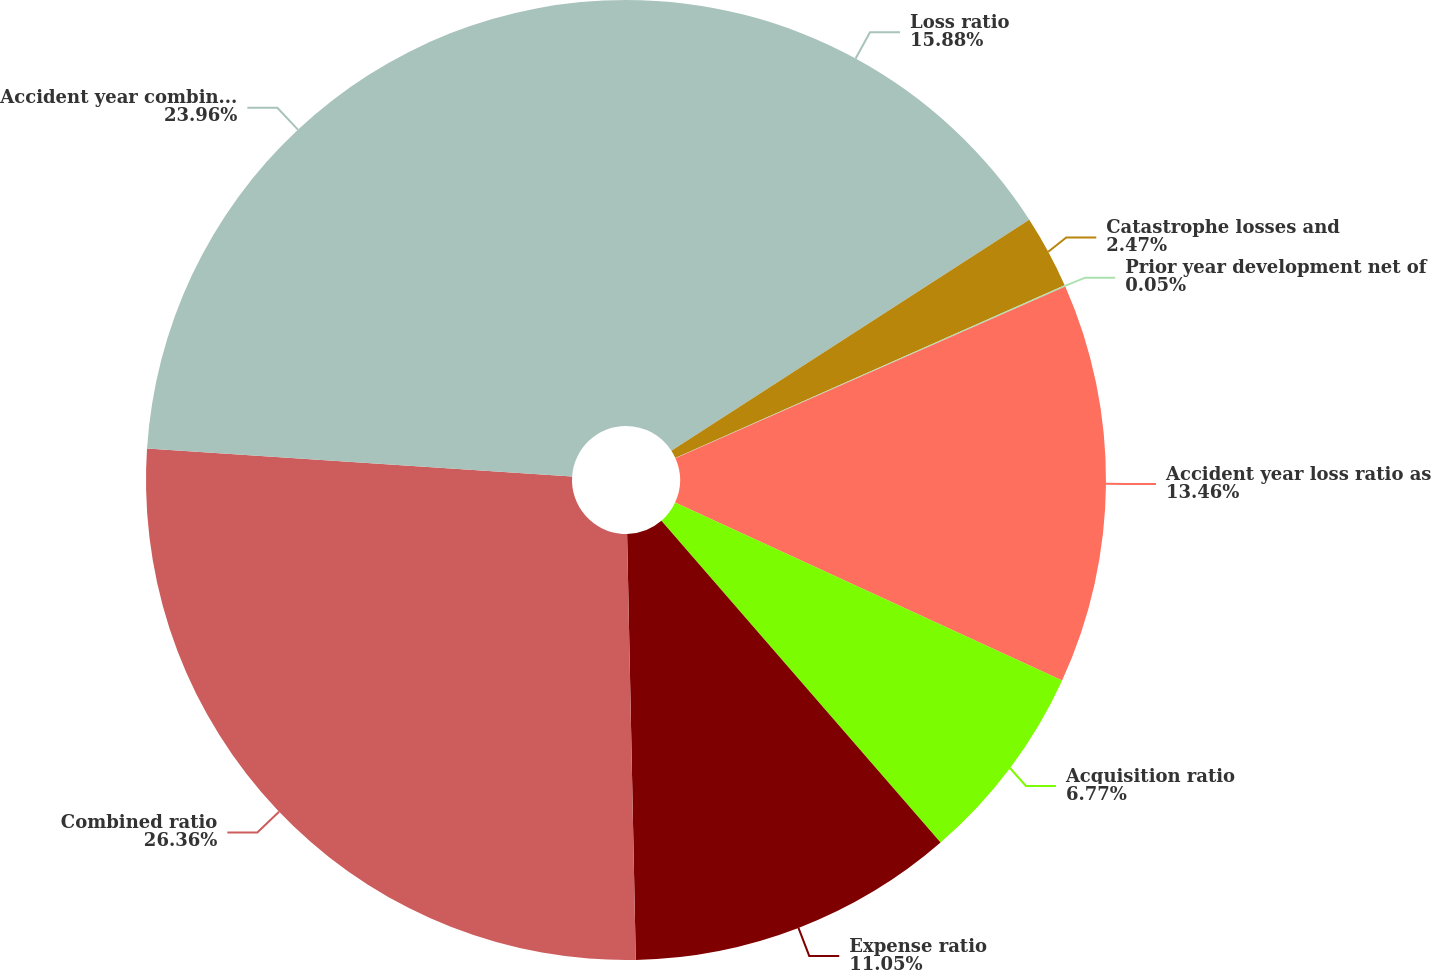Convert chart to OTSL. <chart><loc_0><loc_0><loc_500><loc_500><pie_chart><fcel>Loss ratio<fcel>Catastrophe losses and<fcel>Prior year development net of<fcel>Accident year loss ratio as<fcel>Acquisition ratio<fcel>Expense ratio<fcel>Combined ratio<fcel>Accident year combined ratio<nl><fcel>15.88%<fcel>2.47%<fcel>0.05%<fcel>13.46%<fcel>6.77%<fcel>11.05%<fcel>26.37%<fcel>23.96%<nl></chart> 